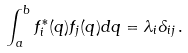<formula> <loc_0><loc_0><loc_500><loc_500>\int _ { a } ^ { b } f ^ { * } _ { i } ( q ) f _ { j } ( q ) d q = \lambda _ { i } \delta _ { i j } \, .</formula> 